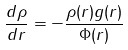Convert formula to latex. <formula><loc_0><loc_0><loc_500><loc_500>\frac { d \rho } { d r } = - \frac { \rho ( r ) g ( r ) } { \Phi ( r ) }</formula> 